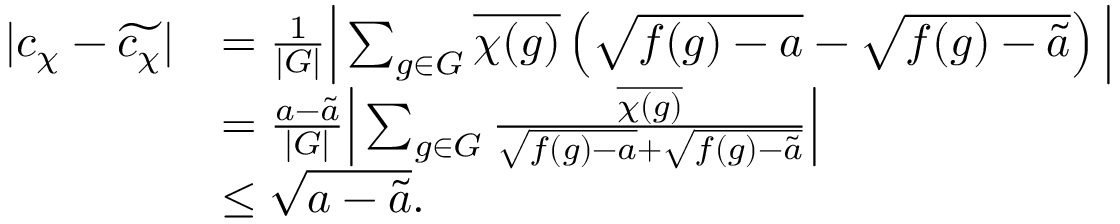Convert formula to latex. <formula><loc_0><loc_0><loc_500><loc_500>\begin{array} { r l } { | c _ { \chi } - \widetilde { c _ { \chi } } | } & { = \frac { 1 } { | G | } \left | \sum _ { g \in G } \overline { \chi ( g ) } \left ( \sqrt { f ( g ) - a } - \sqrt { f ( g ) - \widetilde { a } } \right ) \right | } \\ & { = \frac { a - \widetilde { a } } { | G | } \left | \sum _ { g \in G } \frac { \overline { \chi ( g ) } } { \sqrt { f ( g ) - a } + \sqrt { f ( g ) - \widetilde { a } } } \right | } \\ & { \leq \sqrt { a - \widetilde { a } } . } \end{array}</formula> 